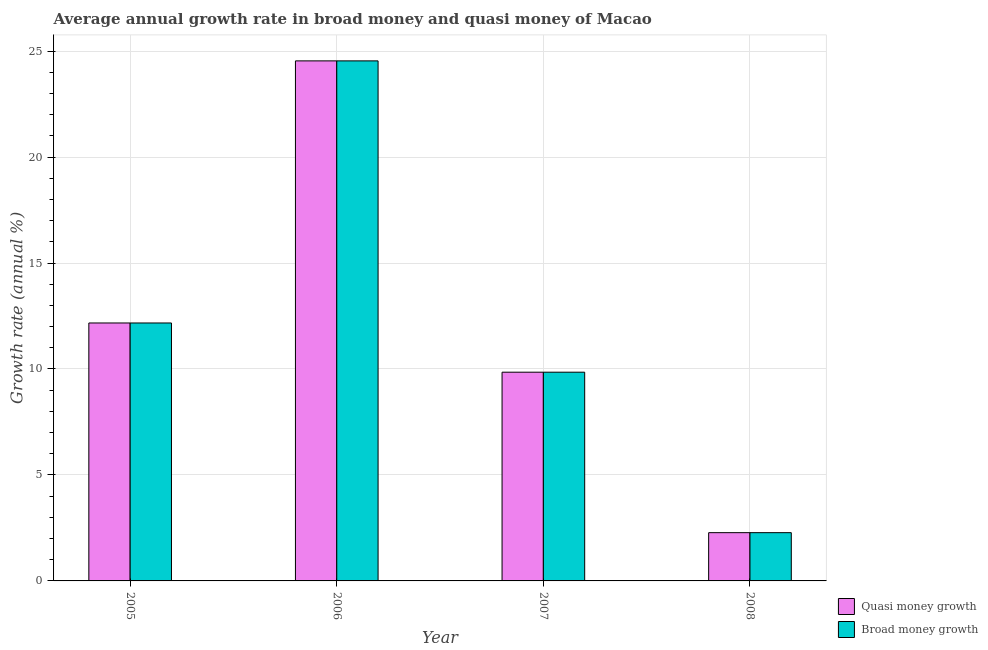How many different coloured bars are there?
Provide a succinct answer. 2. How many groups of bars are there?
Provide a short and direct response. 4. In how many cases, is the number of bars for a given year not equal to the number of legend labels?
Your response must be concise. 0. What is the annual growth rate in broad money in 2008?
Your answer should be very brief. 2.28. Across all years, what is the maximum annual growth rate in quasi money?
Offer a terse response. 24.54. Across all years, what is the minimum annual growth rate in quasi money?
Keep it short and to the point. 2.28. In which year was the annual growth rate in quasi money minimum?
Provide a succinct answer. 2008. What is the total annual growth rate in broad money in the graph?
Your response must be concise. 48.83. What is the difference between the annual growth rate in quasi money in 2007 and that in 2008?
Your response must be concise. 7.57. What is the difference between the annual growth rate in broad money in 2006 and the annual growth rate in quasi money in 2007?
Offer a terse response. 14.69. What is the average annual growth rate in broad money per year?
Provide a succinct answer. 12.21. In the year 2005, what is the difference between the annual growth rate in quasi money and annual growth rate in broad money?
Make the answer very short. 0. What is the ratio of the annual growth rate in broad money in 2005 to that in 2006?
Provide a short and direct response. 0.5. Is the difference between the annual growth rate in quasi money in 2006 and 2008 greater than the difference between the annual growth rate in broad money in 2006 and 2008?
Your response must be concise. No. What is the difference between the highest and the second highest annual growth rate in broad money?
Your answer should be very brief. 12.37. What is the difference between the highest and the lowest annual growth rate in quasi money?
Offer a terse response. 22.26. Is the sum of the annual growth rate in broad money in 2005 and 2007 greater than the maximum annual growth rate in quasi money across all years?
Ensure brevity in your answer.  No. What does the 2nd bar from the left in 2005 represents?
Your response must be concise. Broad money growth. What does the 2nd bar from the right in 2007 represents?
Make the answer very short. Quasi money growth. How many years are there in the graph?
Provide a succinct answer. 4. What is the difference between two consecutive major ticks on the Y-axis?
Provide a short and direct response. 5. Are the values on the major ticks of Y-axis written in scientific E-notation?
Your response must be concise. No. Does the graph contain grids?
Keep it short and to the point. Yes. How are the legend labels stacked?
Your response must be concise. Vertical. What is the title of the graph?
Keep it short and to the point. Average annual growth rate in broad money and quasi money of Macao. What is the label or title of the Y-axis?
Offer a very short reply. Growth rate (annual %). What is the Growth rate (annual %) of Quasi money growth in 2005?
Give a very brief answer. 12.17. What is the Growth rate (annual %) in Broad money growth in 2005?
Your answer should be very brief. 12.17. What is the Growth rate (annual %) in Quasi money growth in 2006?
Make the answer very short. 24.54. What is the Growth rate (annual %) in Broad money growth in 2006?
Provide a short and direct response. 24.54. What is the Growth rate (annual %) in Quasi money growth in 2007?
Give a very brief answer. 9.85. What is the Growth rate (annual %) of Broad money growth in 2007?
Your answer should be compact. 9.85. What is the Growth rate (annual %) of Quasi money growth in 2008?
Offer a very short reply. 2.28. What is the Growth rate (annual %) in Broad money growth in 2008?
Give a very brief answer. 2.28. Across all years, what is the maximum Growth rate (annual %) in Quasi money growth?
Give a very brief answer. 24.54. Across all years, what is the maximum Growth rate (annual %) of Broad money growth?
Your answer should be compact. 24.54. Across all years, what is the minimum Growth rate (annual %) of Quasi money growth?
Your answer should be compact. 2.28. Across all years, what is the minimum Growth rate (annual %) of Broad money growth?
Provide a short and direct response. 2.28. What is the total Growth rate (annual %) in Quasi money growth in the graph?
Your response must be concise. 48.83. What is the total Growth rate (annual %) of Broad money growth in the graph?
Provide a succinct answer. 48.83. What is the difference between the Growth rate (annual %) in Quasi money growth in 2005 and that in 2006?
Provide a succinct answer. -12.37. What is the difference between the Growth rate (annual %) of Broad money growth in 2005 and that in 2006?
Your answer should be very brief. -12.37. What is the difference between the Growth rate (annual %) in Quasi money growth in 2005 and that in 2007?
Your answer should be very brief. 2.32. What is the difference between the Growth rate (annual %) of Broad money growth in 2005 and that in 2007?
Ensure brevity in your answer.  2.32. What is the difference between the Growth rate (annual %) in Quasi money growth in 2005 and that in 2008?
Offer a very short reply. 9.89. What is the difference between the Growth rate (annual %) of Broad money growth in 2005 and that in 2008?
Provide a succinct answer. 9.89. What is the difference between the Growth rate (annual %) of Quasi money growth in 2006 and that in 2007?
Offer a very short reply. 14.69. What is the difference between the Growth rate (annual %) of Broad money growth in 2006 and that in 2007?
Provide a succinct answer. 14.69. What is the difference between the Growth rate (annual %) of Quasi money growth in 2006 and that in 2008?
Provide a succinct answer. 22.26. What is the difference between the Growth rate (annual %) in Broad money growth in 2006 and that in 2008?
Give a very brief answer. 22.26. What is the difference between the Growth rate (annual %) of Quasi money growth in 2007 and that in 2008?
Ensure brevity in your answer.  7.57. What is the difference between the Growth rate (annual %) of Broad money growth in 2007 and that in 2008?
Your answer should be very brief. 7.57. What is the difference between the Growth rate (annual %) of Quasi money growth in 2005 and the Growth rate (annual %) of Broad money growth in 2006?
Keep it short and to the point. -12.37. What is the difference between the Growth rate (annual %) of Quasi money growth in 2005 and the Growth rate (annual %) of Broad money growth in 2007?
Offer a very short reply. 2.32. What is the difference between the Growth rate (annual %) of Quasi money growth in 2005 and the Growth rate (annual %) of Broad money growth in 2008?
Your answer should be compact. 9.89. What is the difference between the Growth rate (annual %) in Quasi money growth in 2006 and the Growth rate (annual %) in Broad money growth in 2007?
Provide a short and direct response. 14.69. What is the difference between the Growth rate (annual %) in Quasi money growth in 2006 and the Growth rate (annual %) in Broad money growth in 2008?
Offer a terse response. 22.26. What is the difference between the Growth rate (annual %) in Quasi money growth in 2007 and the Growth rate (annual %) in Broad money growth in 2008?
Offer a very short reply. 7.57. What is the average Growth rate (annual %) of Quasi money growth per year?
Keep it short and to the point. 12.21. What is the average Growth rate (annual %) in Broad money growth per year?
Ensure brevity in your answer.  12.21. In the year 2005, what is the difference between the Growth rate (annual %) of Quasi money growth and Growth rate (annual %) of Broad money growth?
Make the answer very short. 0. In the year 2007, what is the difference between the Growth rate (annual %) in Quasi money growth and Growth rate (annual %) in Broad money growth?
Provide a short and direct response. 0. What is the ratio of the Growth rate (annual %) in Quasi money growth in 2005 to that in 2006?
Offer a terse response. 0.5. What is the ratio of the Growth rate (annual %) of Broad money growth in 2005 to that in 2006?
Give a very brief answer. 0.5. What is the ratio of the Growth rate (annual %) of Quasi money growth in 2005 to that in 2007?
Your response must be concise. 1.24. What is the ratio of the Growth rate (annual %) of Broad money growth in 2005 to that in 2007?
Your response must be concise. 1.24. What is the ratio of the Growth rate (annual %) of Quasi money growth in 2005 to that in 2008?
Your answer should be very brief. 5.35. What is the ratio of the Growth rate (annual %) of Broad money growth in 2005 to that in 2008?
Give a very brief answer. 5.35. What is the ratio of the Growth rate (annual %) of Quasi money growth in 2006 to that in 2007?
Your answer should be compact. 2.49. What is the ratio of the Growth rate (annual %) of Broad money growth in 2006 to that in 2007?
Offer a very short reply. 2.49. What is the ratio of the Growth rate (annual %) in Quasi money growth in 2006 to that in 2008?
Your answer should be very brief. 10.78. What is the ratio of the Growth rate (annual %) in Broad money growth in 2006 to that in 2008?
Keep it short and to the point. 10.78. What is the ratio of the Growth rate (annual %) of Quasi money growth in 2007 to that in 2008?
Your answer should be very brief. 4.33. What is the ratio of the Growth rate (annual %) of Broad money growth in 2007 to that in 2008?
Your answer should be very brief. 4.33. What is the difference between the highest and the second highest Growth rate (annual %) of Quasi money growth?
Keep it short and to the point. 12.37. What is the difference between the highest and the second highest Growth rate (annual %) in Broad money growth?
Provide a short and direct response. 12.37. What is the difference between the highest and the lowest Growth rate (annual %) in Quasi money growth?
Your answer should be compact. 22.26. What is the difference between the highest and the lowest Growth rate (annual %) in Broad money growth?
Offer a very short reply. 22.26. 